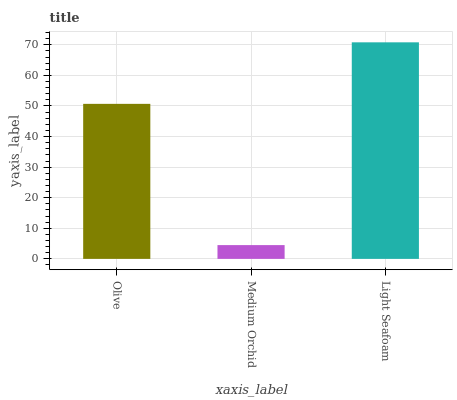Is Medium Orchid the minimum?
Answer yes or no. Yes. Is Light Seafoam the maximum?
Answer yes or no. Yes. Is Light Seafoam the minimum?
Answer yes or no. No. Is Medium Orchid the maximum?
Answer yes or no. No. Is Light Seafoam greater than Medium Orchid?
Answer yes or no. Yes. Is Medium Orchid less than Light Seafoam?
Answer yes or no. Yes. Is Medium Orchid greater than Light Seafoam?
Answer yes or no. No. Is Light Seafoam less than Medium Orchid?
Answer yes or no. No. Is Olive the high median?
Answer yes or no. Yes. Is Olive the low median?
Answer yes or no. Yes. Is Light Seafoam the high median?
Answer yes or no. No. Is Medium Orchid the low median?
Answer yes or no. No. 